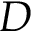<formula> <loc_0><loc_0><loc_500><loc_500>D</formula> 